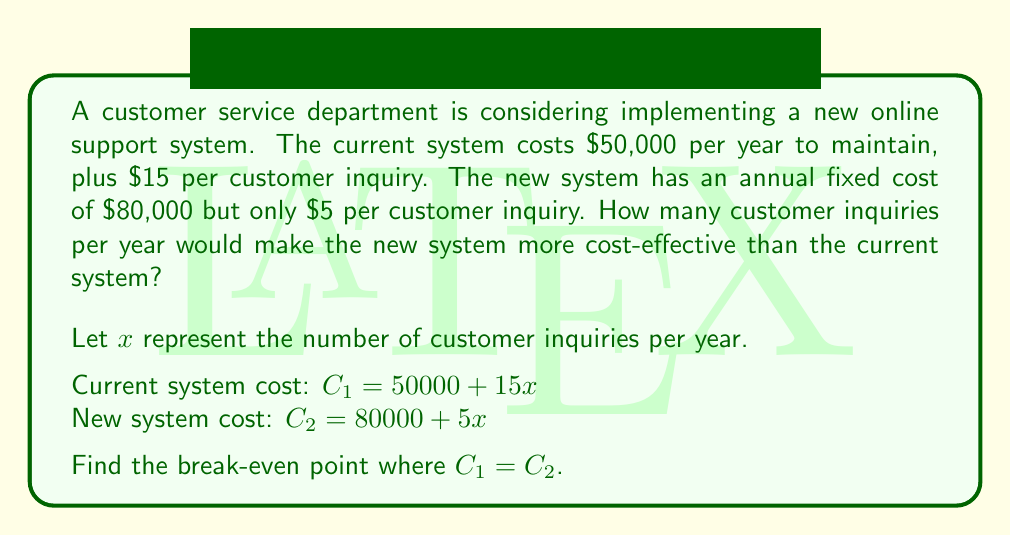Give your solution to this math problem. To find the break-even point, we need to set the two cost equations equal to each other and solve for $x$:

$$C_1 = C_2$$
$$50000 + 15x = 80000 + 5x$$

Now, let's solve this equation step by step:

1) Subtract 50000 from both sides:
   $$15x = 30000 + 5x$$

2) Subtract 5x from both sides:
   $$10x = 30000$$

3) Divide both sides by 10:
   $$x = 3000$$

This means that at 3000 customer inquiries per year, both systems would cost the same amount. To verify:

Current system: $50000 + 15(3000) = 95000$
New system: $80000 + 5(3000) = 95000$

For any number of inquiries greater than 3000, the new system becomes more cost-effective. This is because its per-inquiry cost is lower, so as the volume increases, it becomes increasingly economical compared to the current system.
Answer: The break-even point is 3000 customer inquiries per year. The new online support system becomes more cost-effective when there are more than 3000 customer inquiries annually. 